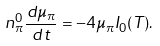Convert formula to latex. <formula><loc_0><loc_0><loc_500><loc_500>n ^ { 0 } _ { \pi } \frac { d \mu _ { \pi } } { d t } = - 4 \mu _ { \pi } I _ { 0 } ( T ) .</formula> 